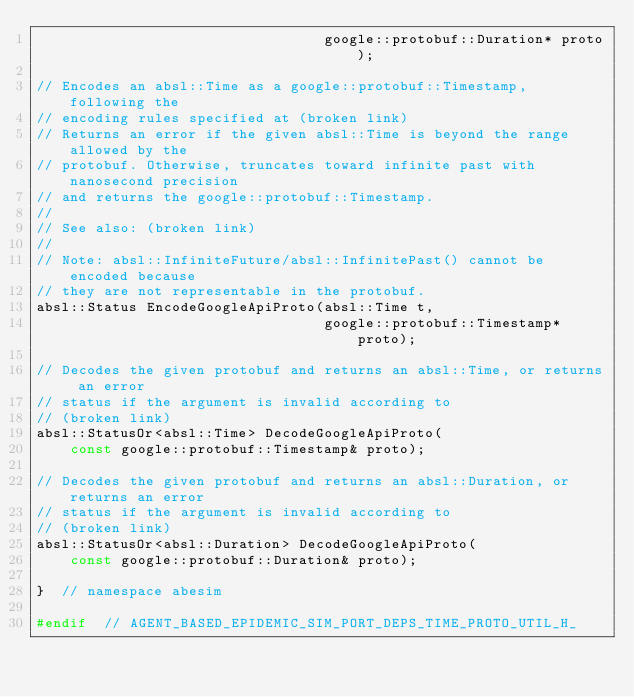<code> <loc_0><loc_0><loc_500><loc_500><_C_>                                  google::protobuf::Duration* proto);

// Encodes an absl::Time as a google::protobuf::Timestamp, following the
// encoding rules specified at (broken link)
// Returns an error if the given absl::Time is beyond the range allowed by the
// protobuf. Otherwise, truncates toward infinite past with nanosecond precision
// and returns the google::protobuf::Timestamp.
//
// See also: (broken link)
//
// Note: absl::InfiniteFuture/absl::InfinitePast() cannot be encoded because
// they are not representable in the protobuf.
absl::Status EncodeGoogleApiProto(absl::Time t,
                                  google::protobuf::Timestamp* proto);

// Decodes the given protobuf and returns an absl::Time, or returns an error
// status if the argument is invalid according to
// (broken link)
absl::StatusOr<absl::Time> DecodeGoogleApiProto(
    const google::protobuf::Timestamp& proto);

// Decodes the given protobuf and returns an absl::Duration, or returns an error
// status if the argument is invalid according to
// (broken link)
absl::StatusOr<absl::Duration> DecodeGoogleApiProto(
    const google::protobuf::Duration& proto);

}  // namespace abesim

#endif  // AGENT_BASED_EPIDEMIC_SIM_PORT_DEPS_TIME_PROTO_UTIL_H_
</code> 